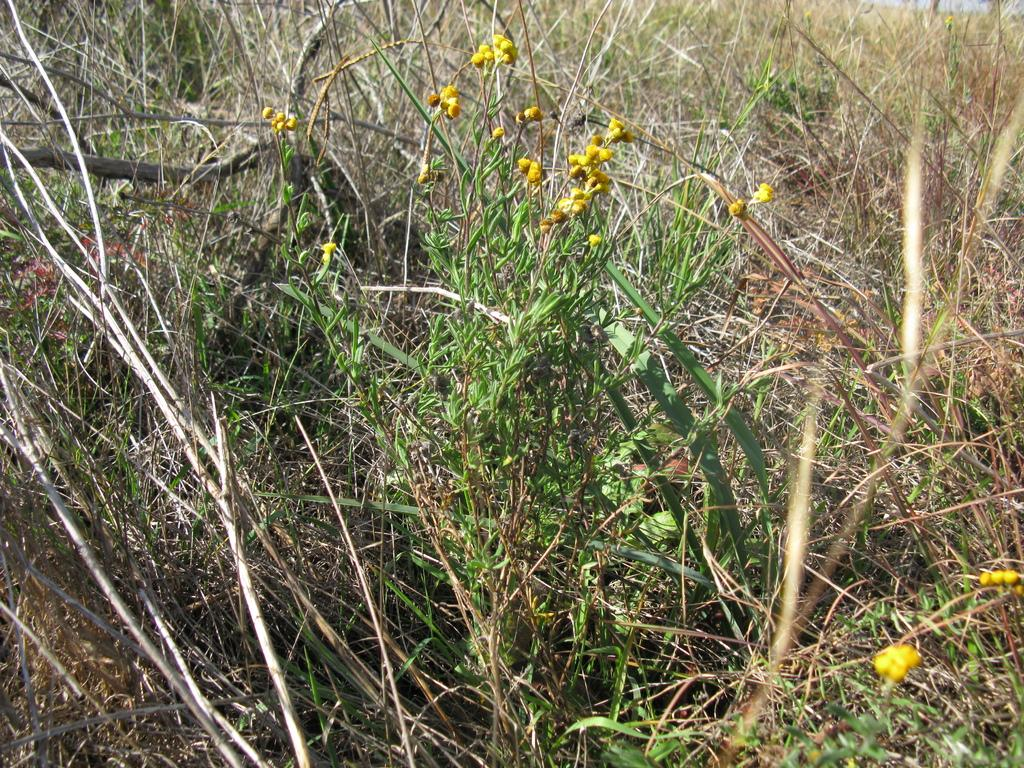What type of environment is depicted in the image? The image contains a grass field. What is the primary color of the grass field? The grass field is primarily green. Are there any structures or objects visible in the grass field? The provided facts do not mention any structures or objects in the grass field. What type of mask is the spy wearing while on their journey through the grass field in the image? There is no spy or mask present in the image; it only contains a grass field. 